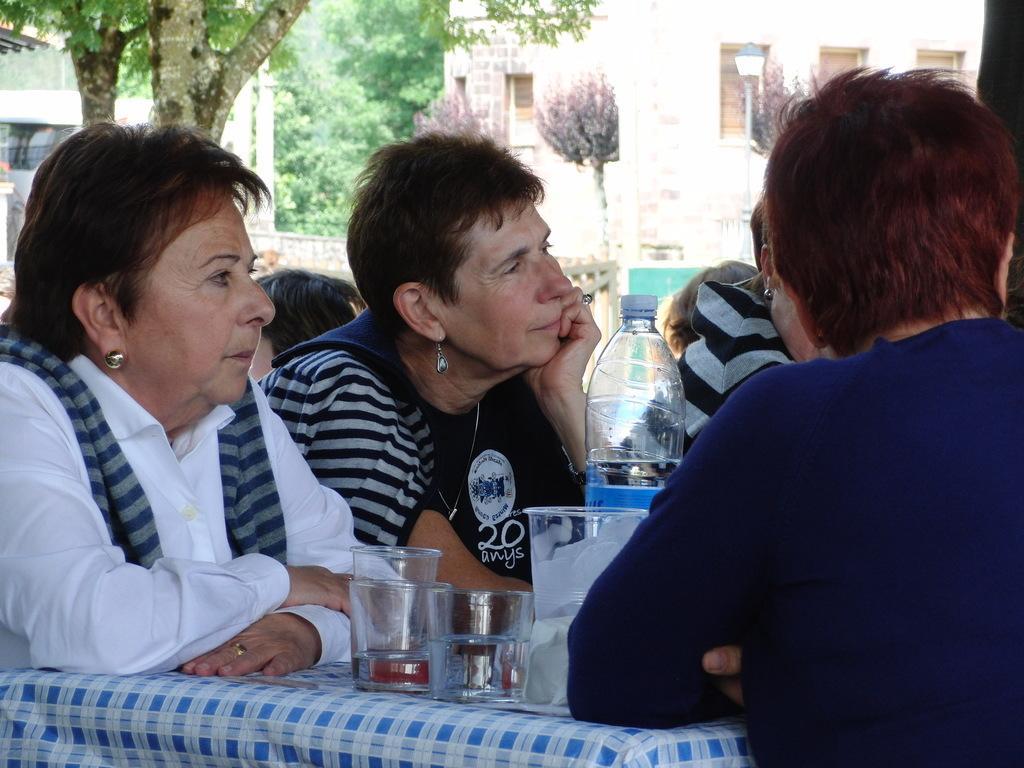Can you describe this image briefly? This picture might be taken from inside the restaurant. In this image, we can see a group of people sitting on the chair in front of the table, at that table, we can see a cloth, few glasses and a water bottle. In the background, we can see a group of people. Outside of the glass window, we can see a building, trees and a window. 